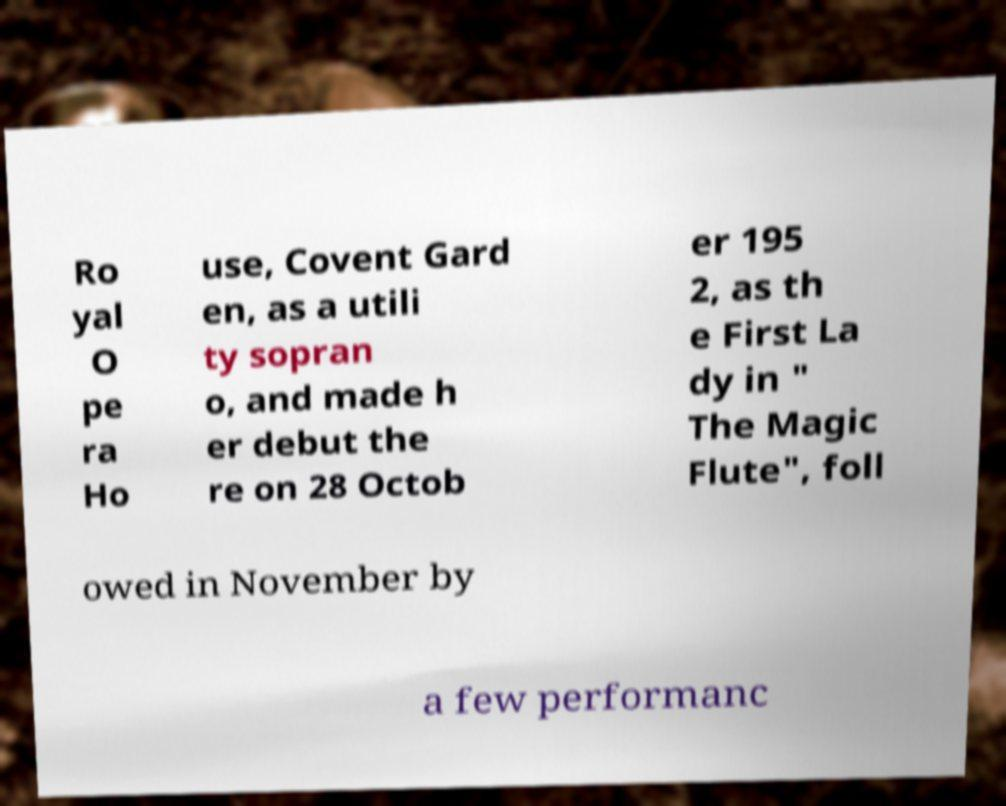I need the written content from this picture converted into text. Can you do that? Ro yal O pe ra Ho use, Covent Gard en, as a utili ty sopran o, and made h er debut the re on 28 Octob er 195 2, as th e First La dy in " The Magic Flute", foll owed in November by a few performanc 